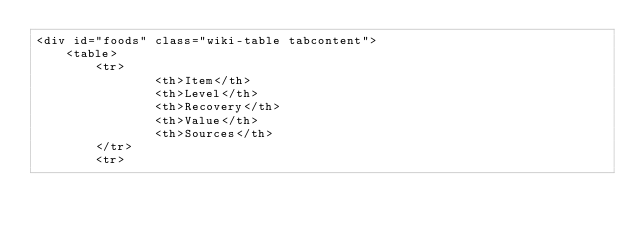<code> <loc_0><loc_0><loc_500><loc_500><_HTML_><div id="foods" class="wiki-table tabcontent">
    <table>
        <tr>
                <th>Item</th>
                <th>Level</th>
                <th>Recovery</th>
                <th>Value</th>
                <th>Sources</th>
        </tr>
        <tr></code> 